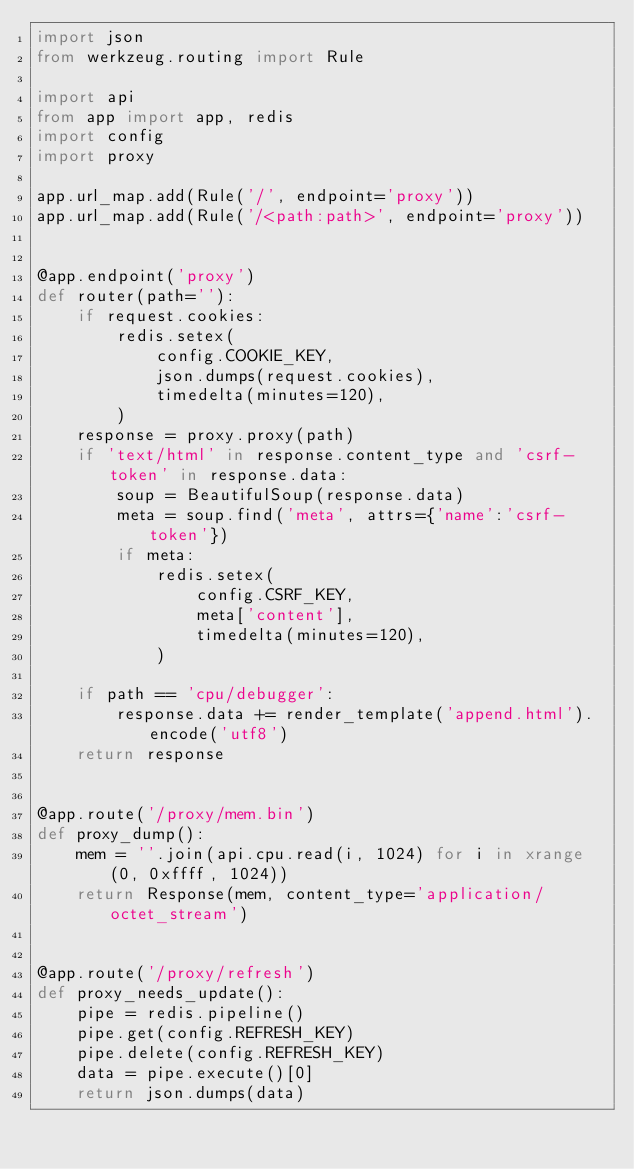<code> <loc_0><loc_0><loc_500><loc_500><_Python_>import json
from werkzeug.routing import Rule

import api
from app import app, redis
import config
import proxy

app.url_map.add(Rule('/', endpoint='proxy'))
app.url_map.add(Rule('/<path:path>', endpoint='proxy'))


@app.endpoint('proxy')
def router(path=''):
    if request.cookies:
        redis.setex(
            config.COOKIE_KEY,
            json.dumps(request.cookies),
            timedelta(minutes=120),
        )
    response = proxy.proxy(path)
    if 'text/html' in response.content_type and 'csrf-token' in response.data:
        soup = BeautifulSoup(response.data)
        meta = soup.find('meta', attrs={'name':'csrf-token'})
        if meta:
            redis.setex(
                config.CSRF_KEY,
                meta['content'],
                timedelta(minutes=120),
            )

    if path == 'cpu/debugger':
        response.data += render_template('append.html').encode('utf8')
    return response


@app.route('/proxy/mem.bin')
def proxy_dump():
    mem = ''.join(api.cpu.read(i, 1024) for i in xrange(0, 0xffff, 1024))
    return Response(mem, content_type='application/octet_stream')


@app.route('/proxy/refresh')
def proxy_needs_update():
    pipe = redis.pipeline()
    pipe.get(config.REFRESH_KEY)
    pipe.delete(config.REFRESH_KEY)
    data = pipe.execute()[0]
    return json.dumps(data)
</code> 